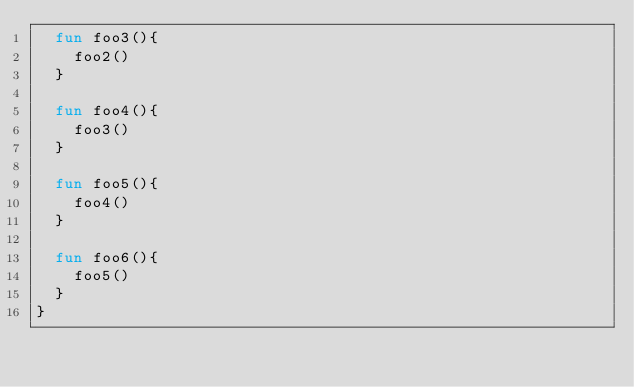Convert code to text. <code><loc_0><loc_0><loc_500><loc_500><_Kotlin_>  fun foo3(){
    foo2()
  }

  fun foo4(){
    foo3()
  }

  fun foo5(){
    foo4()
  }

  fun foo6(){
    foo5()
  }
}</code> 